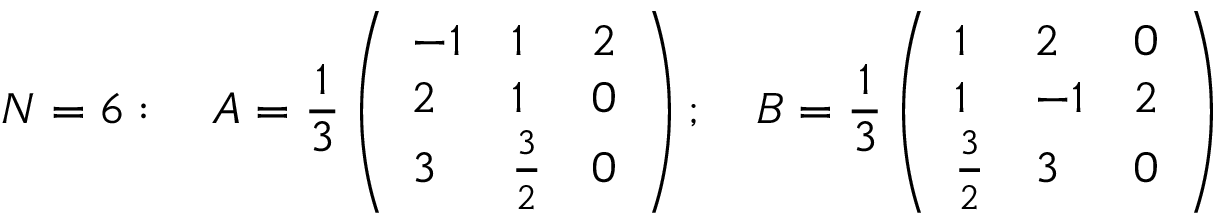<formula> <loc_0><loc_0><loc_500><loc_500>N = 6 \colon \quad A = { \frac { 1 } { 3 } } \left ( \begin{array} { l l l } { - 1 } & { 1 } & { 2 } \\ { 2 } & { 1 } & { 0 } \\ { 3 } & { { { \frac { 3 } { 2 } } } } & { 0 } \end{array} \right ) ; \quad B = { \frac { 1 } { 3 } } \left ( \begin{array} { l l l } { 1 } & { 2 } & { 0 } \\ { 1 } & { - 1 } & { 2 } \\ { { { \frac { 3 } { 2 } } } } & { 3 } & { 0 } \end{array} \right )</formula> 